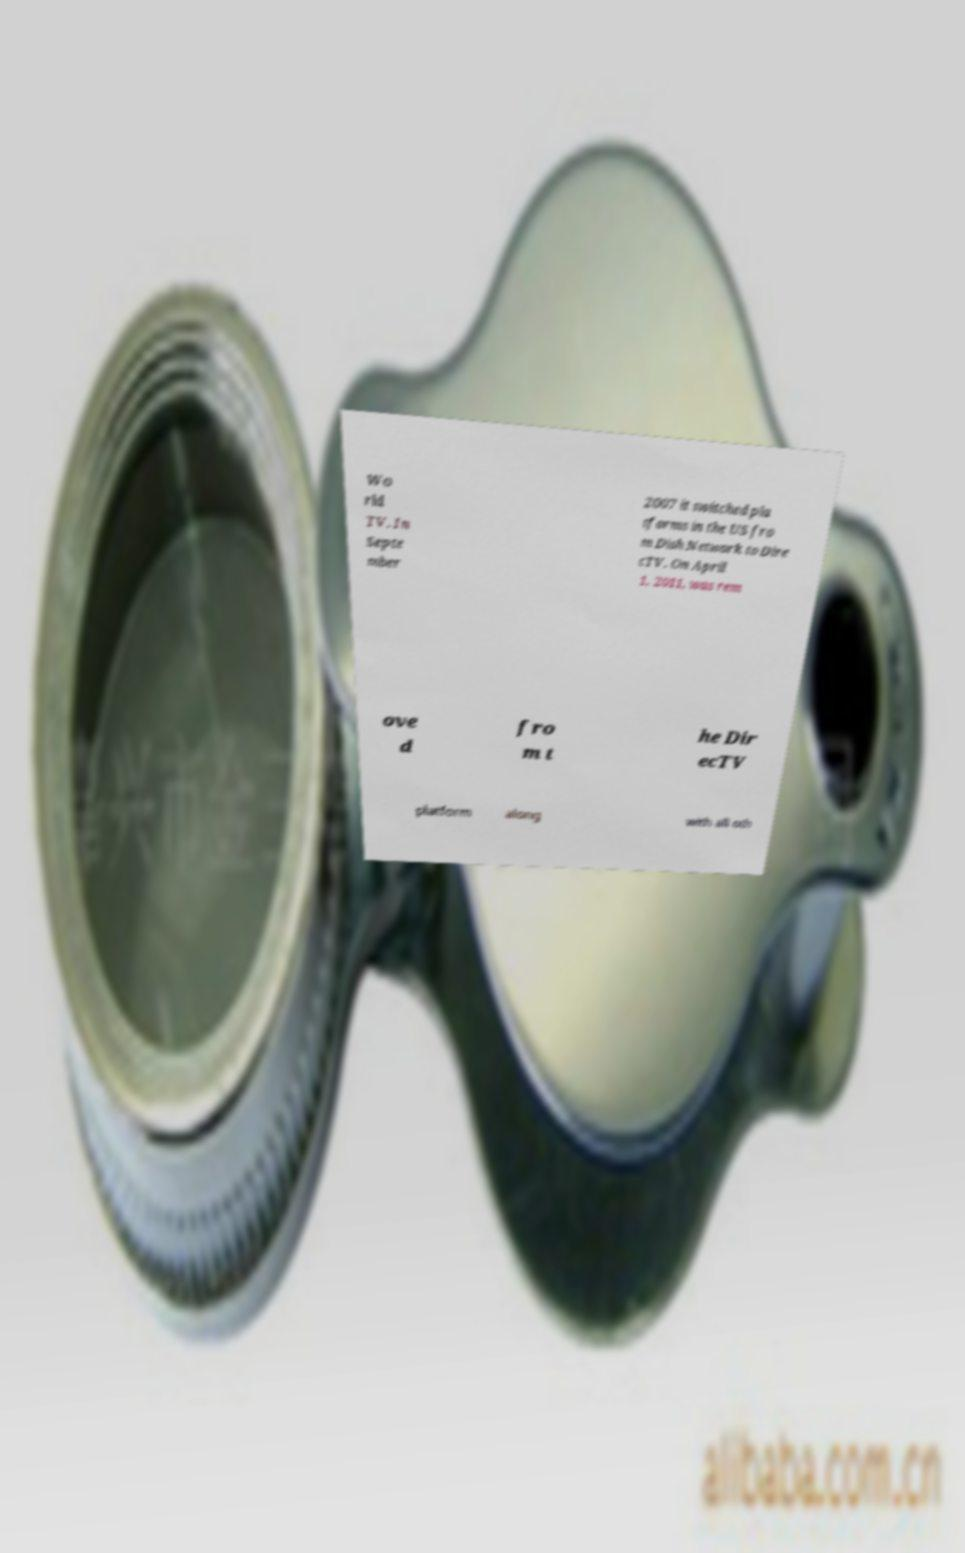Please read and relay the text visible in this image. What does it say? Wo rld TV. In Septe mber 2007 it switched pla tforms in the US fro m Dish Network to Dire cTV. On April 1, 2011, was rem ove d fro m t he Dir ecTV platform along with all oth 